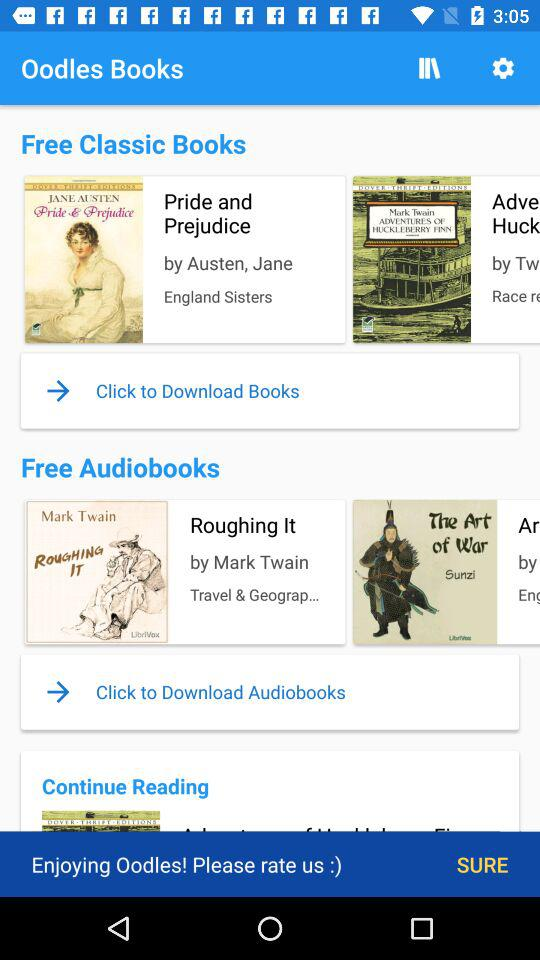Who is the author of the audiobook "Roughing It"? The author of the audiobook "Roughing It" is Mark Twain. 